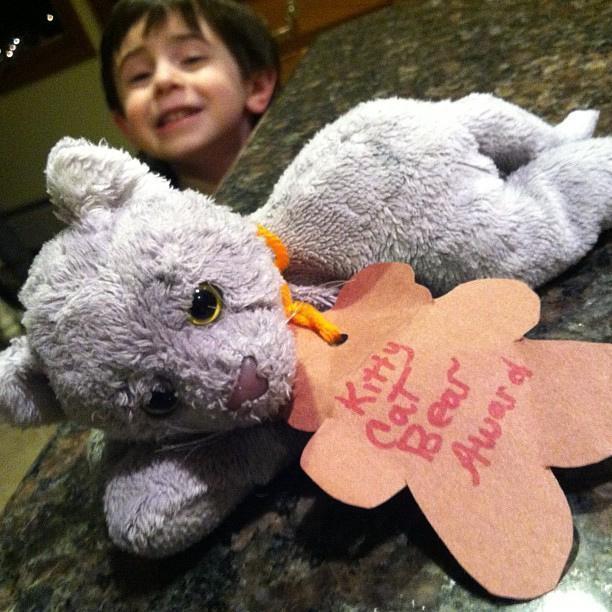What color is the twine wrapped around this little bear's neck?
Answer the question by selecting the correct answer among the 4 following choices.
Options: Blue, purple, orange, red. Orange. 